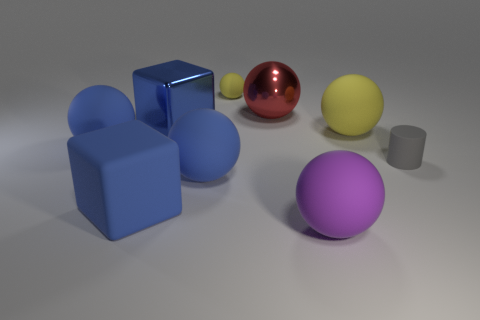Subtract all yellow balls. How many balls are left? 4 Subtract all green cylinders. How many yellow balls are left? 2 Subtract 1 balls. How many balls are left? 5 Add 1 purple rubber spheres. How many objects exist? 10 Subtract all red balls. How many balls are left? 5 Subtract all blocks. How many objects are left? 7 Subtract 0 cyan cylinders. How many objects are left? 9 Subtract all cyan cubes. Subtract all yellow cylinders. How many cubes are left? 2 Subtract all blue cylinders. Subtract all small spheres. How many objects are left? 8 Add 3 small matte spheres. How many small matte spheres are left? 4 